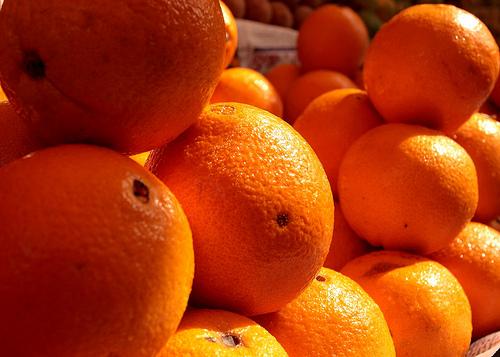What fruit is it?
Quick response, please. Orange. How many oranges are there?
Write a very short answer. 18. What shape are the fruits?
Write a very short answer. Round. 